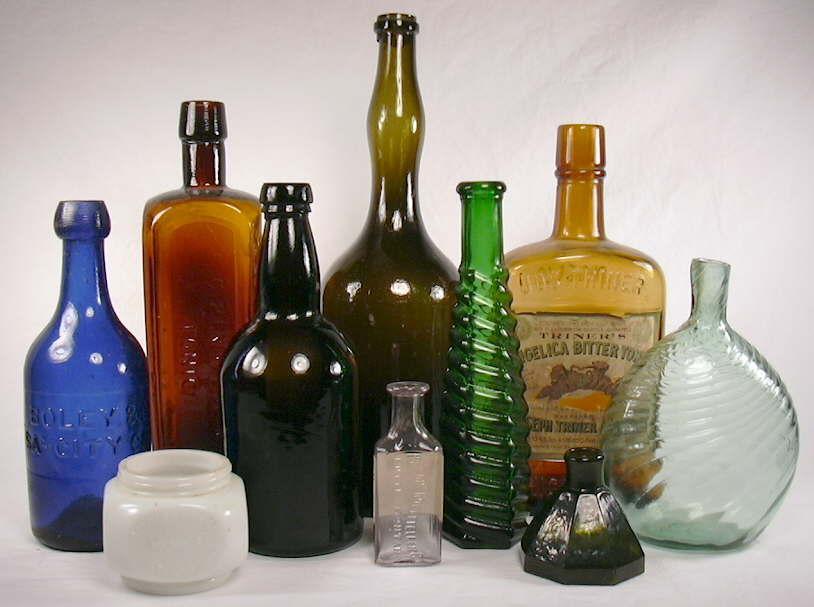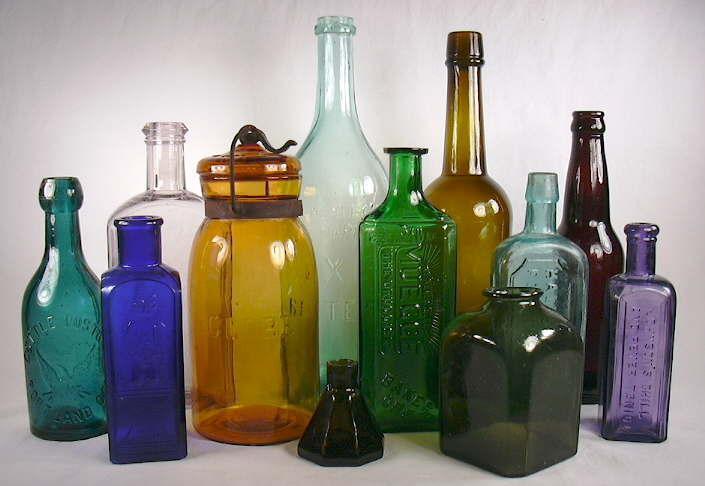The first image is the image on the left, the second image is the image on the right. Examine the images to the left and right. Is the description "The left image contains three or more different bottles while the right image contains only a single bottle." accurate? Answer yes or no. No. The first image is the image on the left, the second image is the image on the right. Given the left and right images, does the statement "Two cobalt blue bottles are sitting among at least 18 other colorful bottles." hold true? Answer yes or no. Yes. 